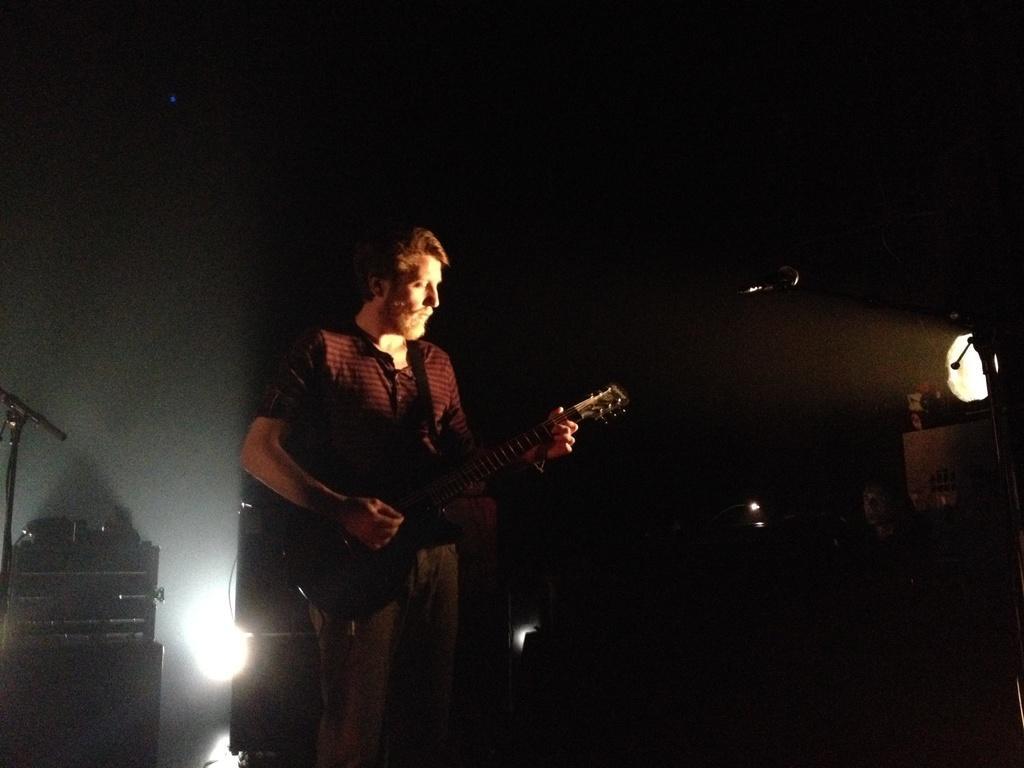Describe this image in one or two sentences. In this picture we can see a man who is playing guitar. This is mike and there is a light. 